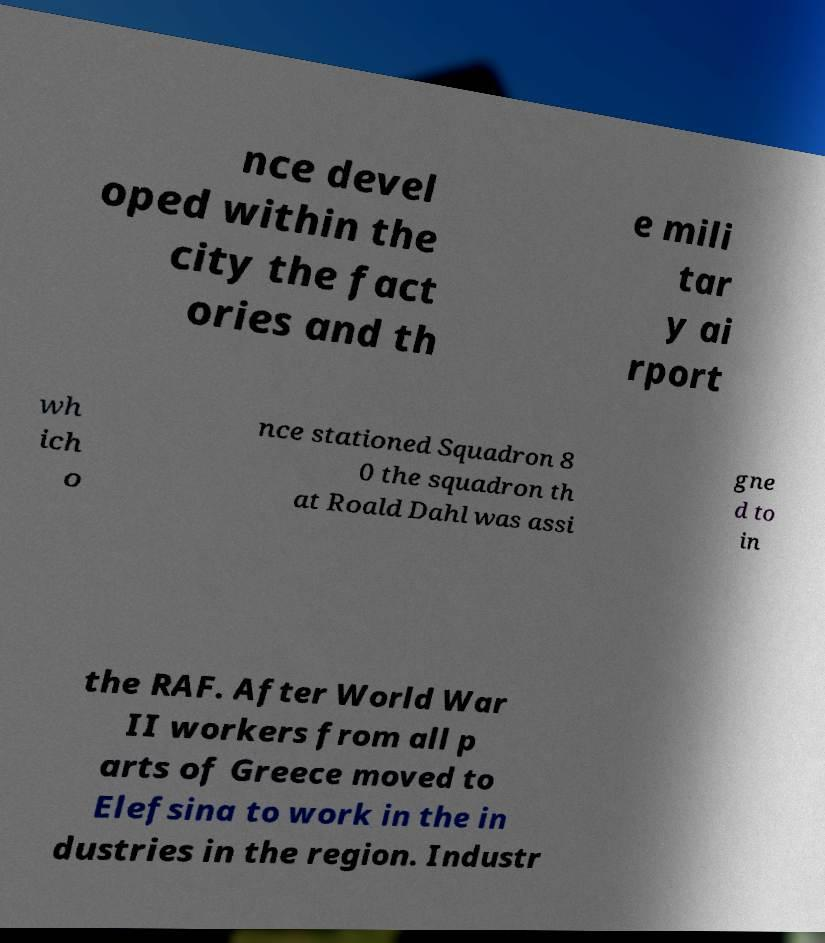Could you extract and type out the text from this image? nce devel oped within the city the fact ories and th e mili tar y ai rport wh ich o nce stationed Squadron 8 0 the squadron th at Roald Dahl was assi gne d to in the RAF. After World War II workers from all p arts of Greece moved to Elefsina to work in the in dustries in the region. Industr 